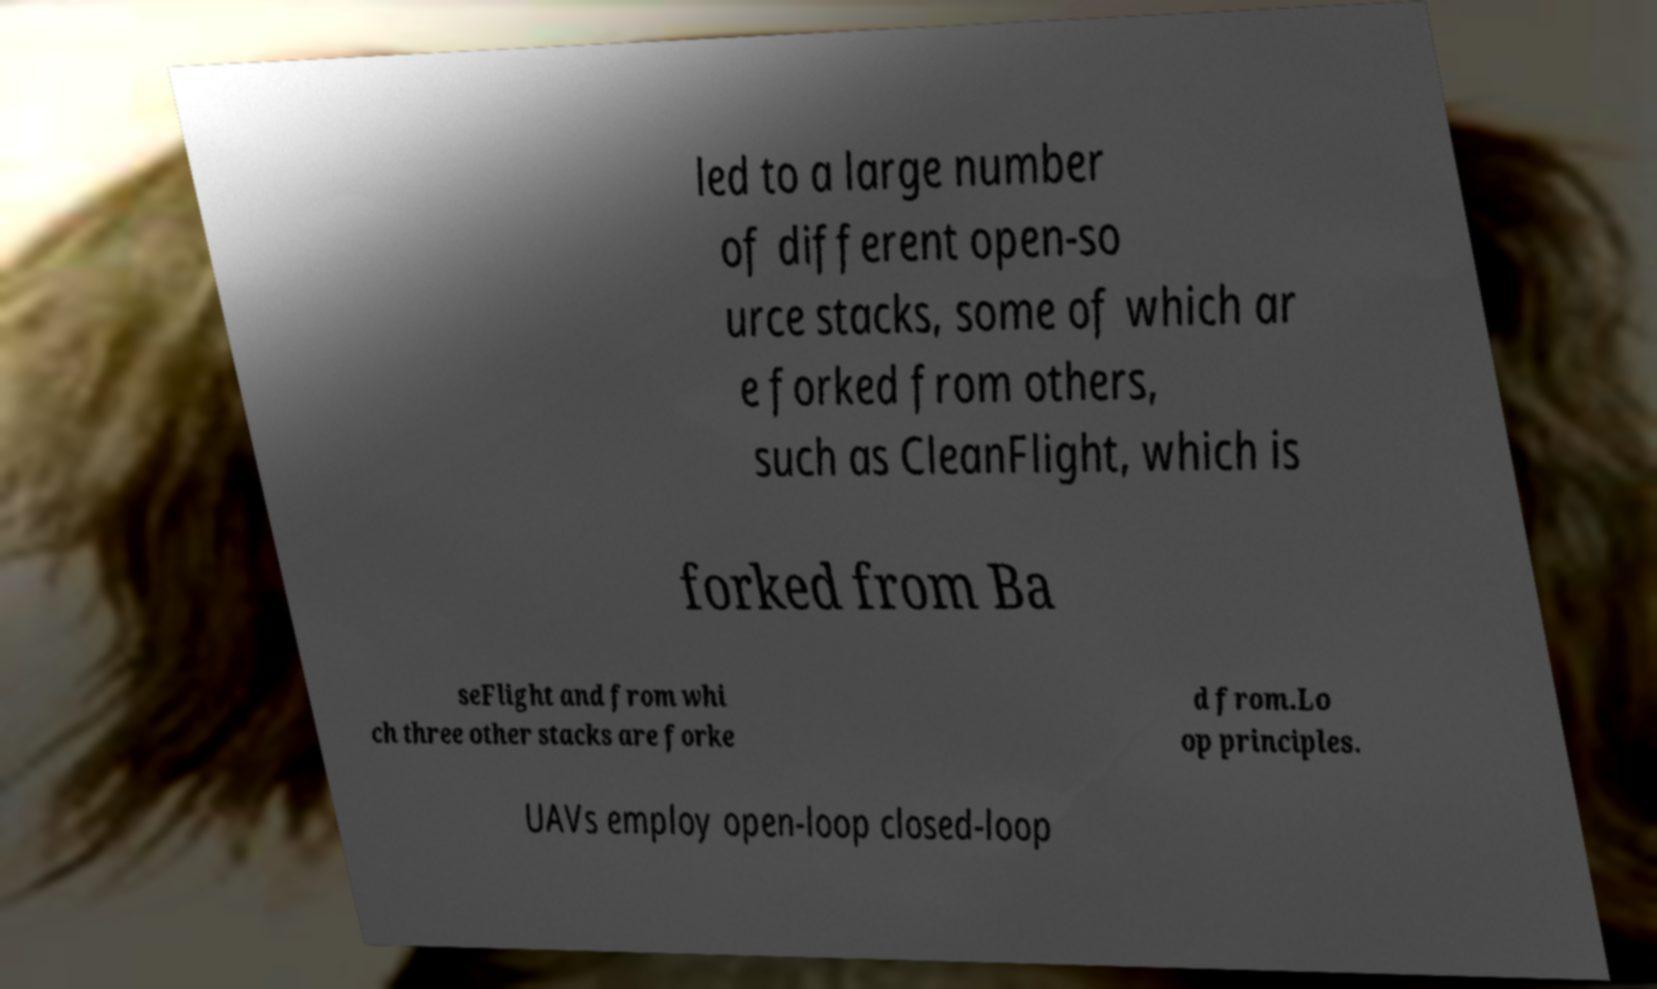Can you read and provide the text displayed in the image?This photo seems to have some interesting text. Can you extract and type it out for me? led to a large number of different open-so urce stacks, some of which ar e forked from others, such as CleanFlight, which is forked from Ba seFlight and from whi ch three other stacks are forke d from.Lo op principles. UAVs employ open-loop closed-loop 